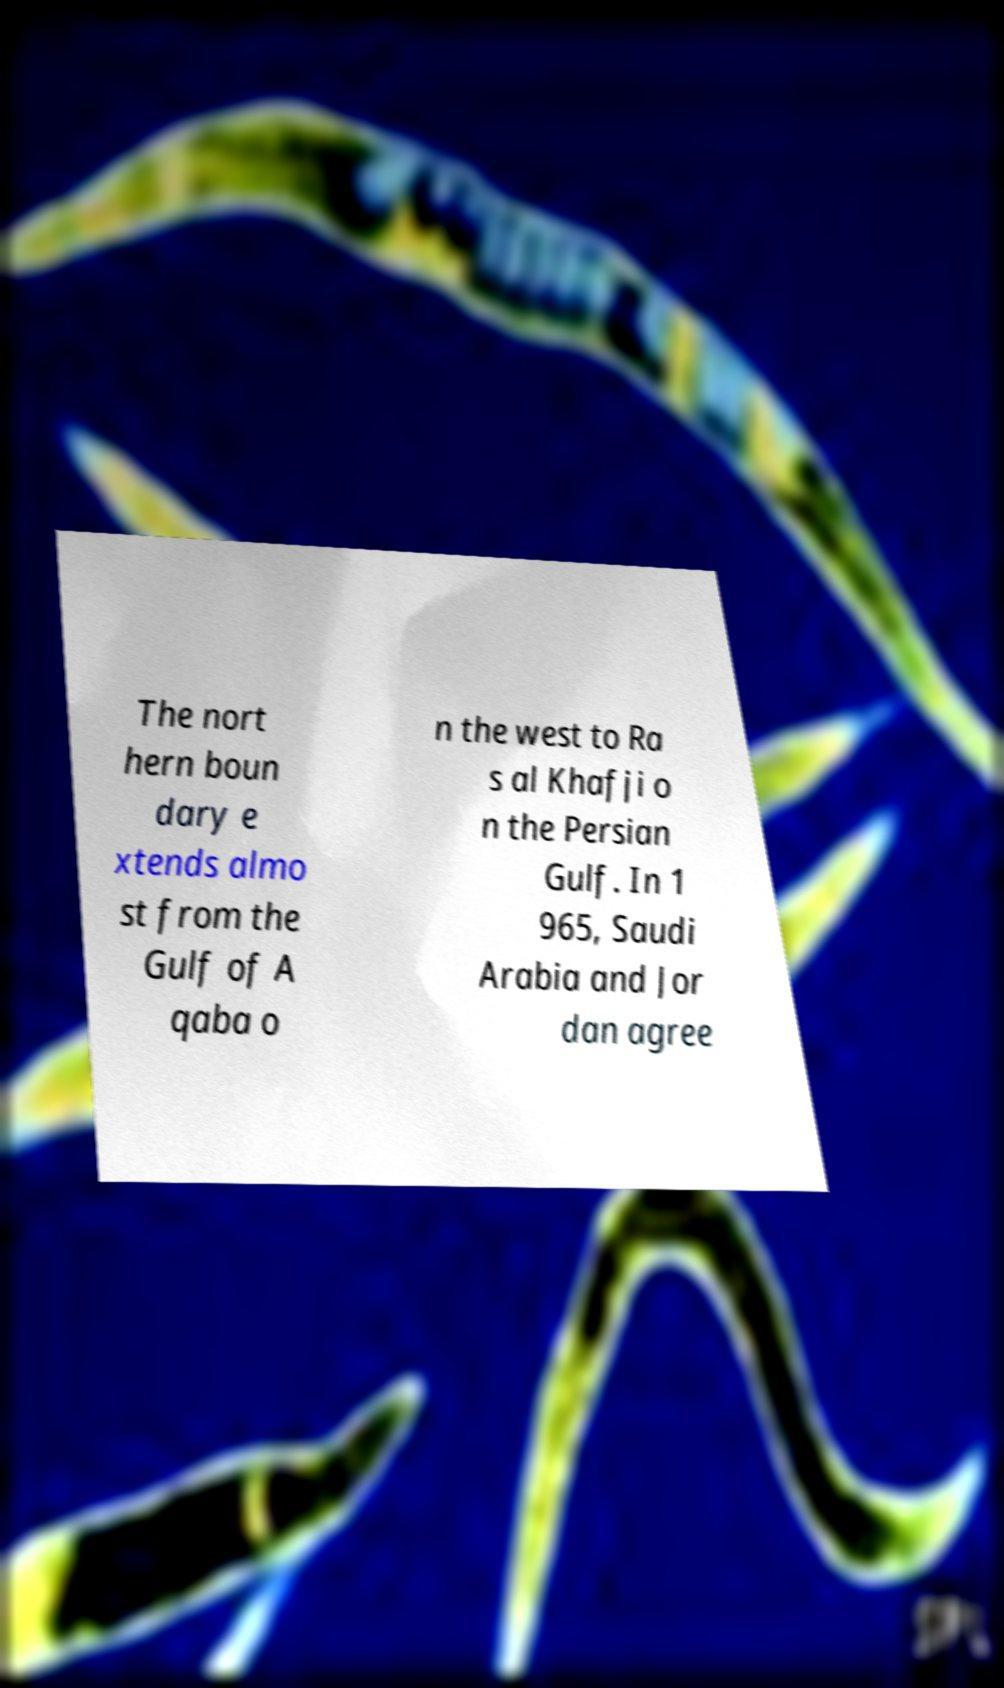I need the written content from this picture converted into text. Can you do that? The nort hern boun dary e xtends almo st from the Gulf of A qaba o n the west to Ra s al Khafji o n the Persian Gulf. In 1 965, Saudi Arabia and Jor dan agree 